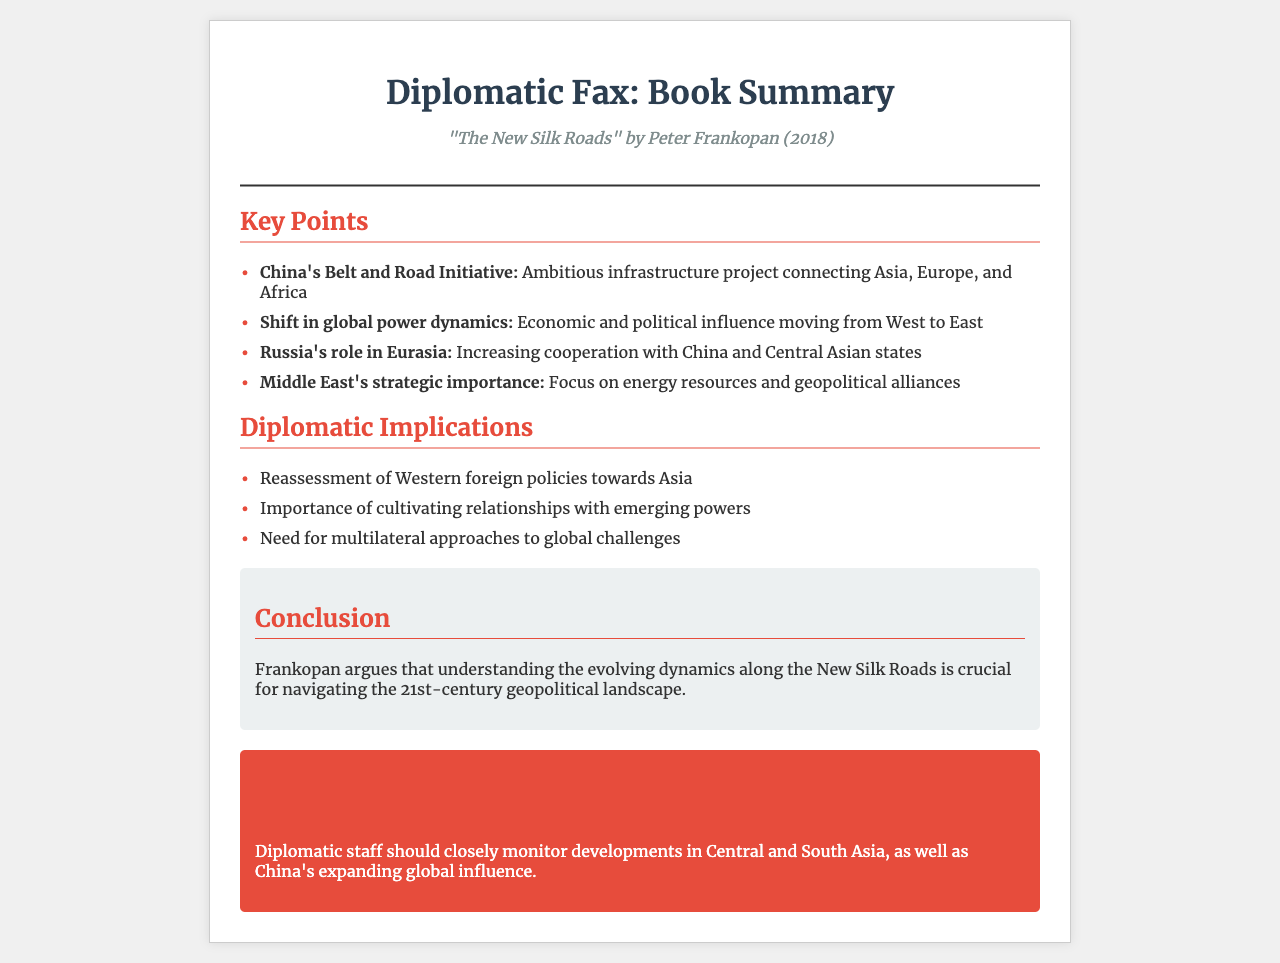What is the title of the book? The title is the main subject of the document, specifically named at the top of the content.
Answer: "The New Silk Roads" Who is the author of the book? The author is mentioned right after the title, indicating who wrote the book.
Answer: Peter Frankopan In what year was the book published? The publication year is provided in the meta section of the document.
Answer: 2018 What is one of the key points regarding China's initiative? This asks for a specific aspect of the key points listed related to China.
Answer: Belt and Road Initiative Name a significant geopolitical region discussed in the book. This requires identifying an important area mentioned in the key points.
Answer: Middle East What does Frankopan emphasize as crucial for navigating geopolitics? This question refers to the conclusion summarizing the author's perspective.
Answer: Understanding evolving dynamics What type of strategies does the document suggest for diplomatic staff? This refers to the action section highlighting recommendations for state diplomats.
Answer: Monitor developments What is a diplomatic implication noted in the document? This asks for one of the points made under diplomatic implications, summarizing its significance.
Answer: Reassessment of Western foreign policies 